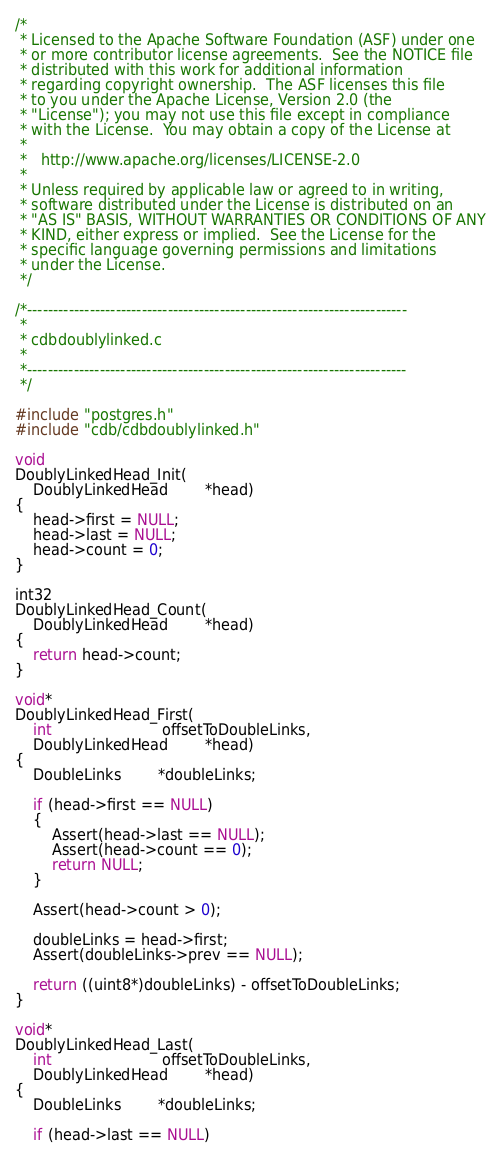Convert code to text. <code><loc_0><loc_0><loc_500><loc_500><_C_>/*
 * Licensed to the Apache Software Foundation (ASF) under one
 * or more contributor license agreements.  See the NOTICE file
 * distributed with this work for additional information
 * regarding copyright ownership.  The ASF licenses this file
 * to you under the Apache License, Version 2.0 (the
 * "License"); you may not use this file except in compliance
 * with the License.  You may obtain a copy of the License at
 * 
 *   http://www.apache.org/licenses/LICENSE-2.0
 * 
 * Unless required by applicable law or agreed to in writing,
 * software distributed under the License is distributed on an
 * "AS IS" BASIS, WITHOUT WARRANTIES OR CONDITIONS OF ANY
 * KIND, either express or implied.  See the License for the
 * specific language governing permissions and limitations
 * under the License.
 */

/*-------------------------------------------------------------------------
 *
 * cdbdoublylinked.c
 *
 *-------------------------------------------------------------------------
 */
 
#include "postgres.h"
#include "cdb/cdbdoublylinked.h"

void
DoublyLinkedHead_Init(
	DoublyLinkedHead		*head)
{
	head->first = NULL;
	head->last = NULL;
	head->count = 0;
}

int32
DoublyLinkedHead_Count(
	DoublyLinkedHead		*head)
{
	return head->count;
}

void*
DoublyLinkedHead_First(
	int						offsetToDoubleLinks,
	DoublyLinkedHead		*head)
{
	DoubleLinks		*doubleLinks;
	
	if (head->first == NULL)
	{
		Assert(head->last == NULL);
		Assert(head->count == 0);
		return NULL;
	}

	Assert(head->count > 0);

	doubleLinks = head->first;
	Assert(doubleLinks->prev == NULL);

	return ((uint8*)doubleLinks) - offsetToDoubleLinks;
}

void*
DoublyLinkedHead_Last(
	int						offsetToDoubleLinks,
	DoublyLinkedHead		*head)
{
	DoubleLinks		*doubleLinks;
	
	if (head->last == NULL)</code> 